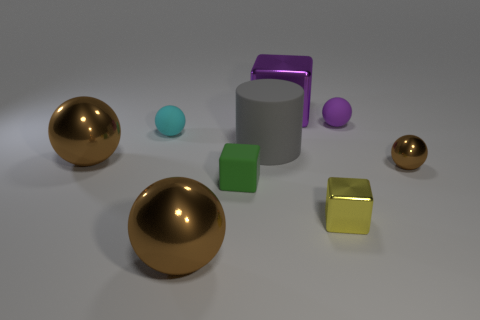Subtract all cyan cubes. How many brown balls are left? 3 Subtract all cyan balls. How many balls are left? 4 Subtract all small purple balls. How many balls are left? 4 Subtract all red balls. Subtract all purple cylinders. How many balls are left? 5 Add 1 large yellow metallic spheres. How many objects exist? 10 Subtract all cubes. How many objects are left? 6 Add 6 tiny rubber balls. How many tiny rubber balls are left? 8 Add 9 green metallic cylinders. How many green metallic cylinders exist? 9 Subtract 0 cyan blocks. How many objects are left? 9 Subtract all metallic objects. Subtract all large purple shiny blocks. How many objects are left? 3 